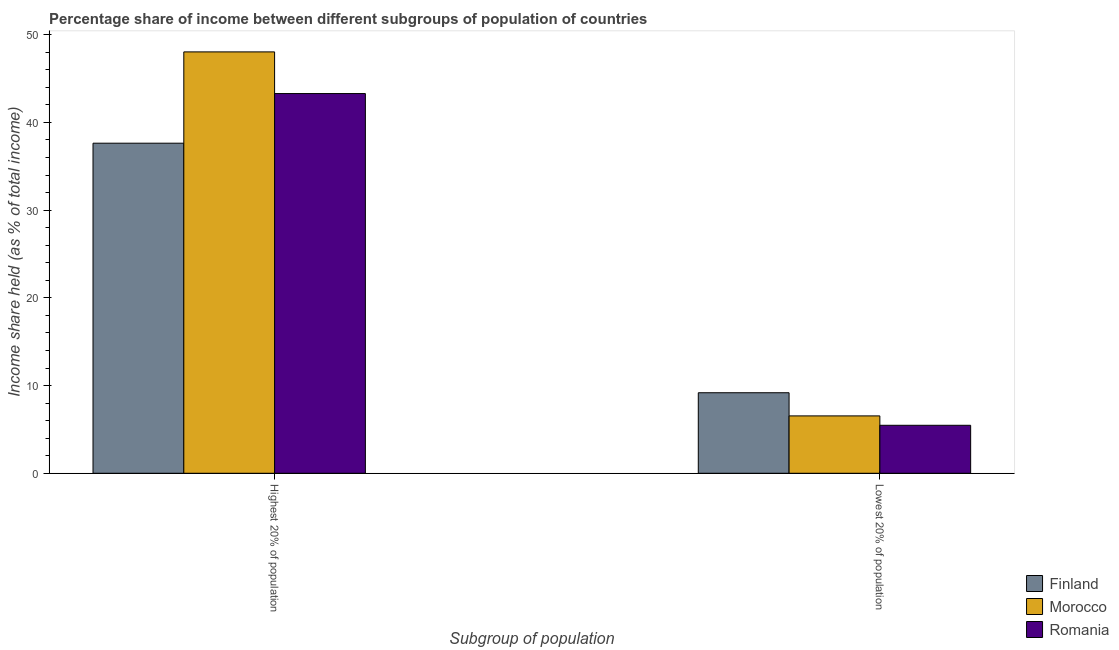How many groups of bars are there?
Your response must be concise. 2. Are the number of bars on each tick of the X-axis equal?
Provide a succinct answer. Yes. How many bars are there on the 1st tick from the left?
Offer a very short reply. 3. How many bars are there on the 2nd tick from the right?
Your answer should be very brief. 3. What is the label of the 2nd group of bars from the left?
Offer a very short reply. Lowest 20% of population. What is the income share held by highest 20% of the population in Morocco?
Keep it short and to the point. 48.04. Across all countries, what is the maximum income share held by highest 20% of the population?
Your response must be concise. 48.04. Across all countries, what is the minimum income share held by highest 20% of the population?
Provide a succinct answer. 37.63. In which country was the income share held by highest 20% of the population maximum?
Your answer should be very brief. Morocco. What is the total income share held by lowest 20% of the population in the graph?
Your answer should be very brief. 21.19. What is the difference between the income share held by highest 20% of the population in Romania and that in Morocco?
Make the answer very short. -4.75. What is the difference between the income share held by lowest 20% of the population in Morocco and the income share held by highest 20% of the population in Finland?
Your answer should be very brief. -31.09. What is the average income share held by highest 20% of the population per country?
Provide a succinct answer. 42.99. What is the difference between the income share held by lowest 20% of the population and income share held by highest 20% of the population in Finland?
Provide a succinct answer. -28.45. In how many countries, is the income share held by highest 20% of the population greater than 30 %?
Offer a very short reply. 3. What is the ratio of the income share held by highest 20% of the population in Finland to that in Morocco?
Offer a terse response. 0.78. What does the 3rd bar from the left in Highest 20% of population represents?
Give a very brief answer. Romania. How many bars are there?
Your answer should be compact. 6. Are the values on the major ticks of Y-axis written in scientific E-notation?
Your answer should be compact. No. Where does the legend appear in the graph?
Give a very brief answer. Bottom right. How many legend labels are there?
Make the answer very short. 3. What is the title of the graph?
Keep it short and to the point. Percentage share of income between different subgroups of population of countries. Does "Monaco" appear as one of the legend labels in the graph?
Your answer should be very brief. No. What is the label or title of the X-axis?
Make the answer very short. Subgroup of population. What is the label or title of the Y-axis?
Keep it short and to the point. Income share held (as % of total income). What is the Income share held (as % of total income) of Finland in Highest 20% of population?
Ensure brevity in your answer.  37.63. What is the Income share held (as % of total income) of Morocco in Highest 20% of population?
Provide a succinct answer. 48.04. What is the Income share held (as % of total income) of Romania in Highest 20% of population?
Your response must be concise. 43.29. What is the Income share held (as % of total income) in Finland in Lowest 20% of population?
Your answer should be very brief. 9.18. What is the Income share held (as % of total income) in Morocco in Lowest 20% of population?
Offer a terse response. 6.54. What is the Income share held (as % of total income) in Romania in Lowest 20% of population?
Make the answer very short. 5.47. Across all Subgroup of population, what is the maximum Income share held (as % of total income) in Finland?
Provide a short and direct response. 37.63. Across all Subgroup of population, what is the maximum Income share held (as % of total income) in Morocco?
Make the answer very short. 48.04. Across all Subgroup of population, what is the maximum Income share held (as % of total income) of Romania?
Your answer should be very brief. 43.29. Across all Subgroup of population, what is the minimum Income share held (as % of total income) of Finland?
Ensure brevity in your answer.  9.18. Across all Subgroup of population, what is the minimum Income share held (as % of total income) in Morocco?
Your response must be concise. 6.54. Across all Subgroup of population, what is the minimum Income share held (as % of total income) in Romania?
Keep it short and to the point. 5.47. What is the total Income share held (as % of total income) in Finland in the graph?
Your answer should be very brief. 46.81. What is the total Income share held (as % of total income) in Morocco in the graph?
Make the answer very short. 54.58. What is the total Income share held (as % of total income) of Romania in the graph?
Provide a succinct answer. 48.76. What is the difference between the Income share held (as % of total income) of Finland in Highest 20% of population and that in Lowest 20% of population?
Provide a succinct answer. 28.45. What is the difference between the Income share held (as % of total income) of Morocco in Highest 20% of population and that in Lowest 20% of population?
Offer a very short reply. 41.5. What is the difference between the Income share held (as % of total income) in Romania in Highest 20% of population and that in Lowest 20% of population?
Your answer should be very brief. 37.82. What is the difference between the Income share held (as % of total income) of Finland in Highest 20% of population and the Income share held (as % of total income) of Morocco in Lowest 20% of population?
Ensure brevity in your answer.  31.09. What is the difference between the Income share held (as % of total income) in Finland in Highest 20% of population and the Income share held (as % of total income) in Romania in Lowest 20% of population?
Your answer should be very brief. 32.16. What is the difference between the Income share held (as % of total income) of Morocco in Highest 20% of population and the Income share held (as % of total income) of Romania in Lowest 20% of population?
Your answer should be very brief. 42.57. What is the average Income share held (as % of total income) in Finland per Subgroup of population?
Offer a very short reply. 23.41. What is the average Income share held (as % of total income) in Morocco per Subgroup of population?
Your answer should be compact. 27.29. What is the average Income share held (as % of total income) of Romania per Subgroup of population?
Your response must be concise. 24.38. What is the difference between the Income share held (as % of total income) of Finland and Income share held (as % of total income) of Morocco in Highest 20% of population?
Keep it short and to the point. -10.41. What is the difference between the Income share held (as % of total income) of Finland and Income share held (as % of total income) of Romania in Highest 20% of population?
Ensure brevity in your answer.  -5.66. What is the difference between the Income share held (as % of total income) of Morocco and Income share held (as % of total income) of Romania in Highest 20% of population?
Keep it short and to the point. 4.75. What is the difference between the Income share held (as % of total income) in Finland and Income share held (as % of total income) in Morocco in Lowest 20% of population?
Offer a terse response. 2.64. What is the difference between the Income share held (as % of total income) in Finland and Income share held (as % of total income) in Romania in Lowest 20% of population?
Give a very brief answer. 3.71. What is the difference between the Income share held (as % of total income) in Morocco and Income share held (as % of total income) in Romania in Lowest 20% of population?
Offer a terse response. 1.07. What is the ratio of the Income share held (as % of total income) in Finland in Highest 20% of population to that in Lowest 20% of population?
Your response must be concise. 4.1. What is the ratio of the Income share held (as % of total income) of Morocco in Highest 20% of population to that in Lowest 20% of population?
Give a very brief answer. 7.35. What is the ratio of the Income share held (as % of total income) of Romania in Highest 20% of population to that in Lowest 20% of population?
Ensure brevity in your answer.  7.91. What is the difference between the highest and the second highest Income share held (as % of total income) of Finland?
Give a very brief answer. 28.45. What is the difference between the highest and the second highest Income share held (as % of total income) in Morocco?
Offer a terse response. 41.5. What is the difference between the highest and the second highest Income share held (as % of total income) of Romania?
Your response must be concise. 37.82. What is the difference between the highest and the lowest Income share held (as % of total income) of Finland?
Ensure brevity in your answer.  28.45. What is the difference between the highest and the lowest Income share held (as % of total income) of Morocco?
Your answer should be compact. 41.5. What is the difference between the highest and the lowest Income share held (as % of total income) in Romania?
Keep it short and to the point. 37.82. 